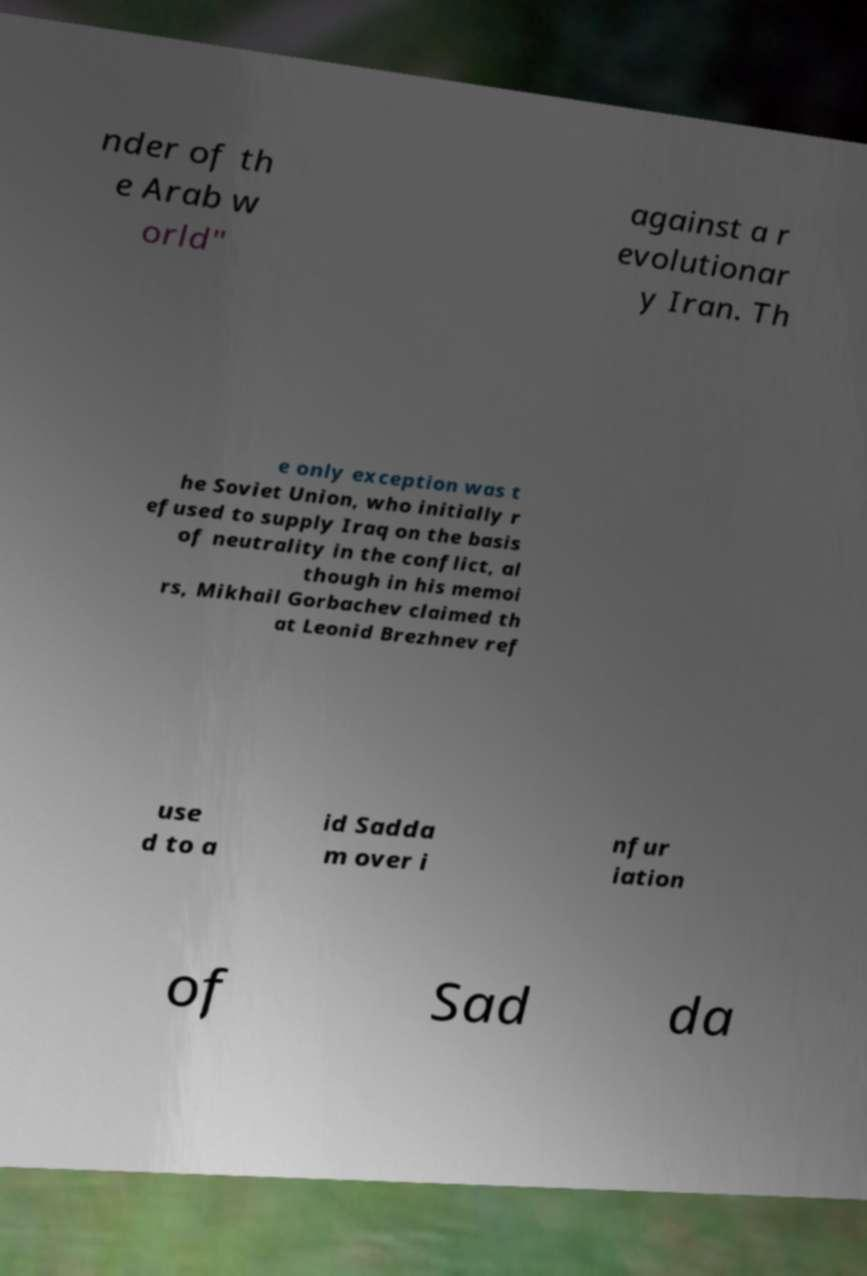Please identify and transcribe the text found in this image. nder of th e Arab w orld" against a r evolutionar y Iran. Th e only exception was t he Soviet Union, who initially r efused to supply Iraq on the basis of neutrality in the conflict, al though in his memoi rs, Mikhail Gorbachev claimed th at Leonid Brezhnev ref use d to a id Sadda m over i nfur iation of Sad da 